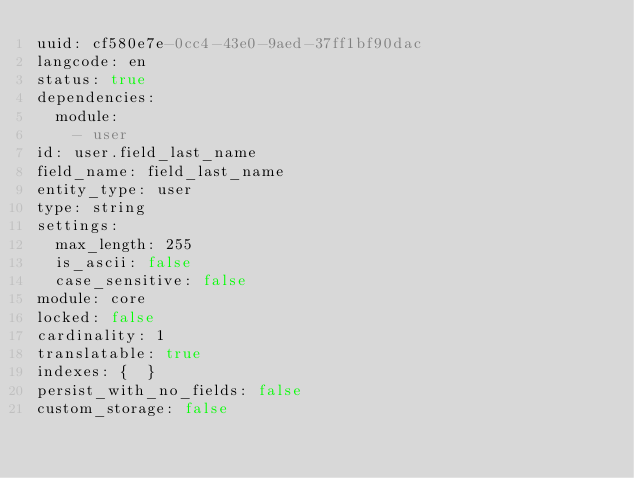Convert code to text. <code><loc_0><loc_0><loc_500><loc_500><_YAML_>uuid: cf580e7e-0cc4-43e0-9aed-37ff1bf90dac
langcode: en
status: true
dependencies:
  module:
    - user
id: user.field_last_name
field_name: field_last_name
entity_type: user
type: string
settings:
  max_length: 255
  is_ascii: false
  case_sensitive: false
module: core
locked: false
cardinality: 1
translatable: true
indexes: {  }
persist_with_no_fields: false
custom_storage: false
</code> 